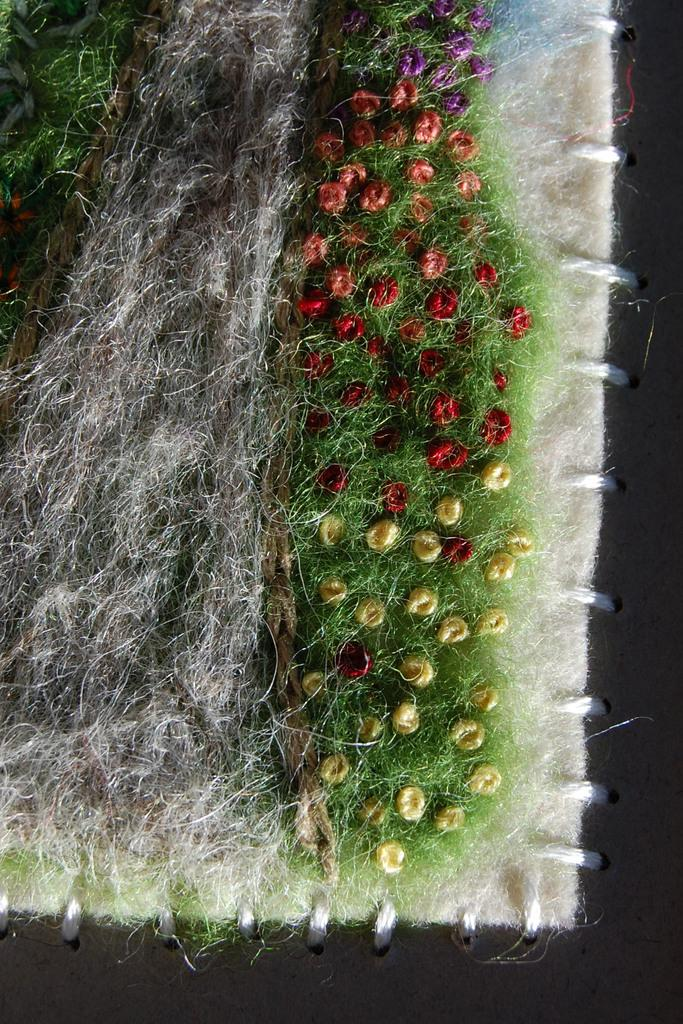What type of vegetation can be seen in the image? There is dry grass and flowers in the image. Can you describe the flowers in the image? Unfortunately, the facts provided do not give specific details about the flowers. However, we can confirm that there are flowers present. What type of tax is being discussed in the image? There is no mention of tax in the image, as it primarily features dry grass and flowers. How many buttons can be seen on the flowers in the image? There are no buttons present on the flowers in the image, as they are natural plant structures. 